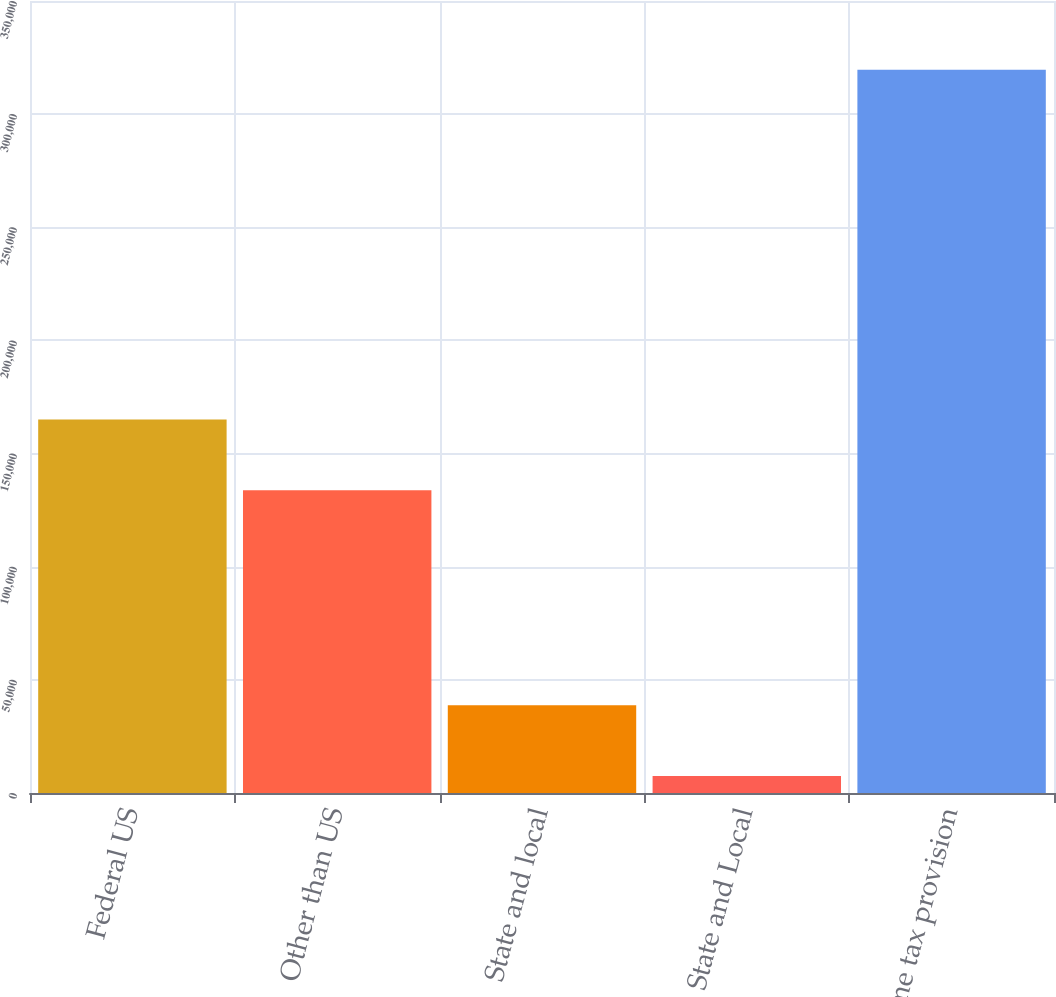Convert chart. <chart><loc_0><loc_0><loc_500><loc_500><bar_chart><fcel>Federal US<fcel>Other than US<fcel>State and local<fcel>State and Local<fcel>Income tax provision<nl><fcel>165038<fcel>133827<fcel>38742.5<fcel>7532<fcel>319637<nl></chart> 